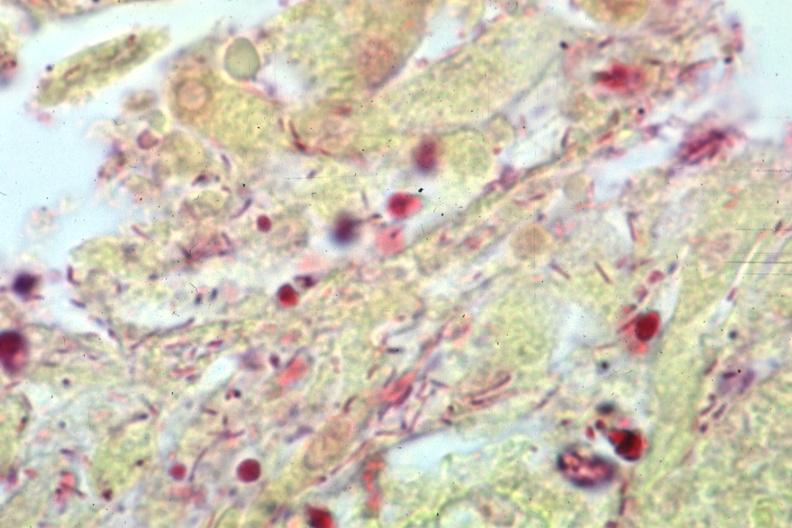s cm present?
Answer the question using a single word or phrase. No 